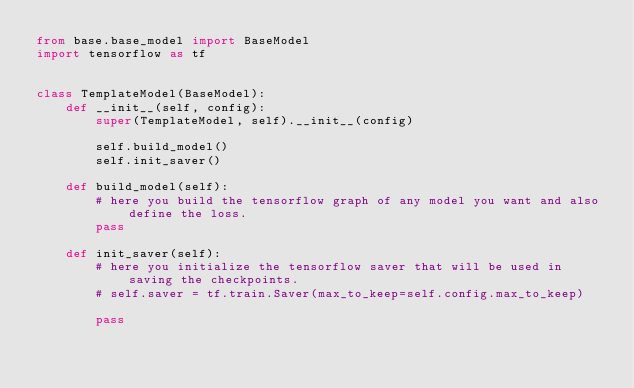<code> <loc_0><loc_0><loc_500><loc_500><_Python_>from base.base_model import BaseModel
import tensorflow as tf


class TemplateModel(BaseModel):
    def __init__(self, config):
        super(TemplateModel, self).__init__(config)

        self.build_model()
        self.init_saver()

    def build_model(self):
        # here you build the tensorflow graph of any model you want and also define the loss.
        pass

    def init_saver(self):
        # here you initialize the tensorflow saver that will be used in saving the checkpoints.
        # self.saver = tf.train.Saver(max_to_keep=self.config.max_to_keep)

        pass
</code> 